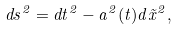<formula> <loc_0><loc_0><loc_500><loc_500>d s ^ { 2 } = d t ^ { 2 } - a ^ { 2 } ( t ) d { \vec { x } } ^ { 2 } ,</formula> 